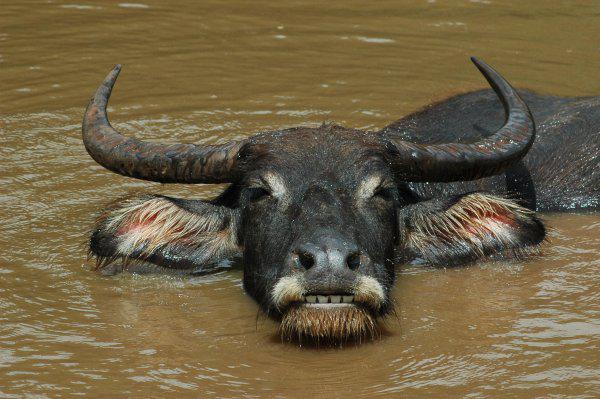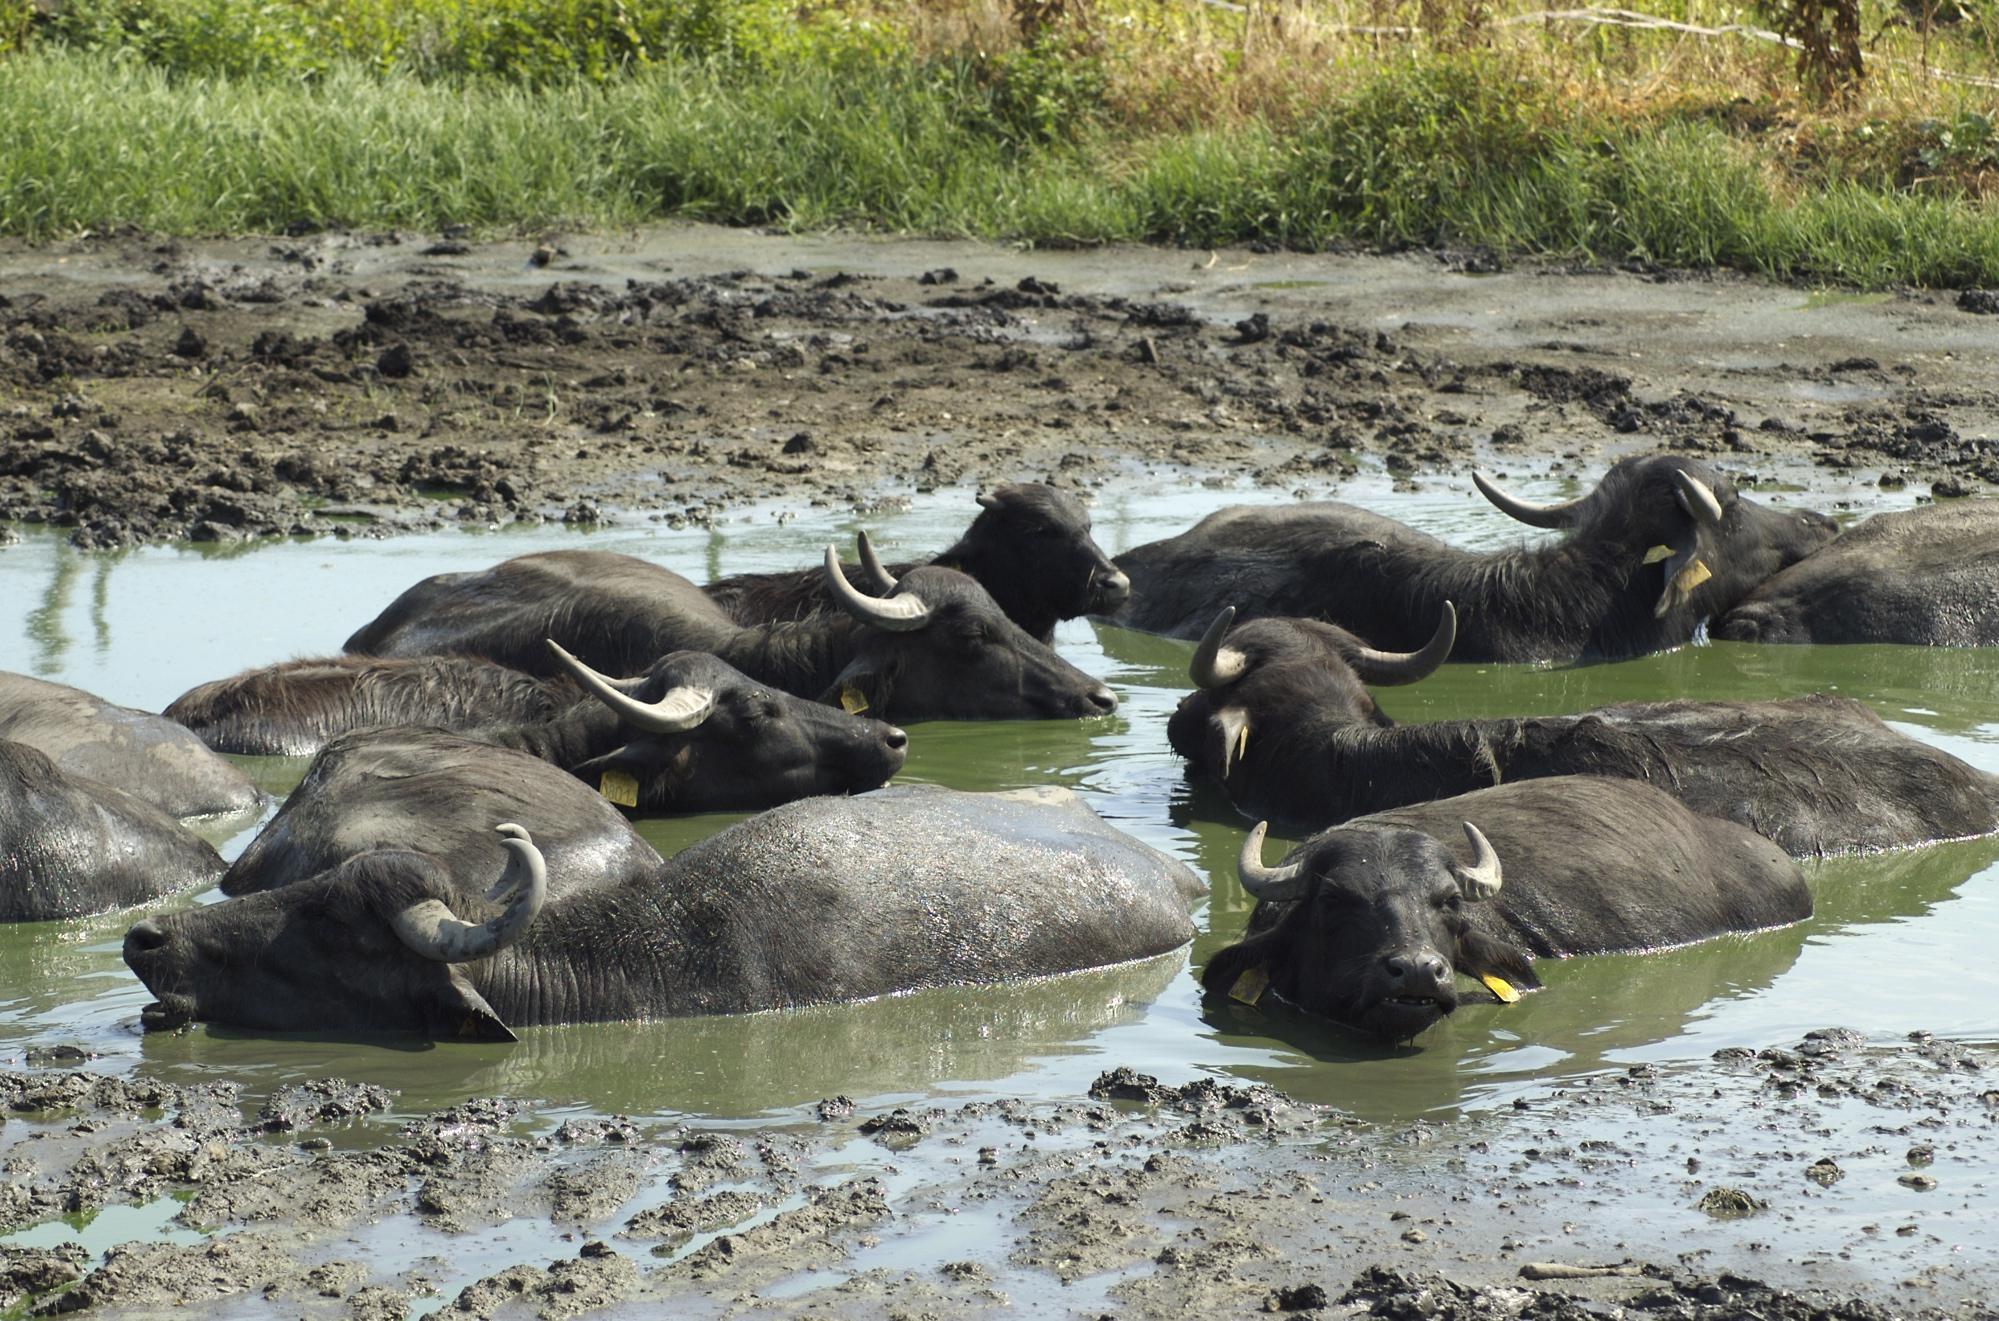The first image is the image on the left, the second image is the image on the right. Evaluate the accuracy of this statement regarding the images: "There are three animals in total.". Is it true? Answer yes or no. No. 